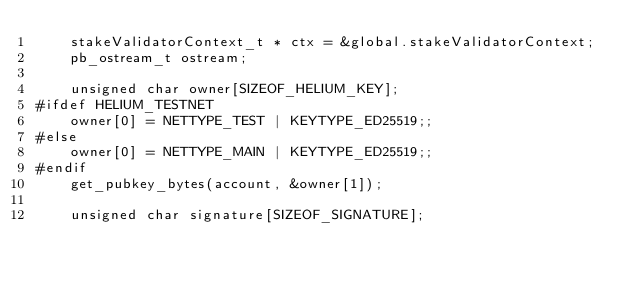<code> <loc_0><loc_0><loc_500><loc_500><_C_>    stakeValidatorContext_t * ctx = &global.stakeValidatorContext;
    pb_ostream_t ostream;

    unsigned char owner[SIZEOF_HELIUM_KEY];
#ifdef HELIUM_TESTNET
    owner[0] = NETTYPE_TEST | KEYTYPE_ED25519;;
#else
    owner[0] = NETTYPE_MAIN | KEYTYPE_ED25519;;
#endif
    get_pubkey_bytes(account, &owner[1]);

    unsigned char signature[SIZEOF_SIGNATURE];</code> 